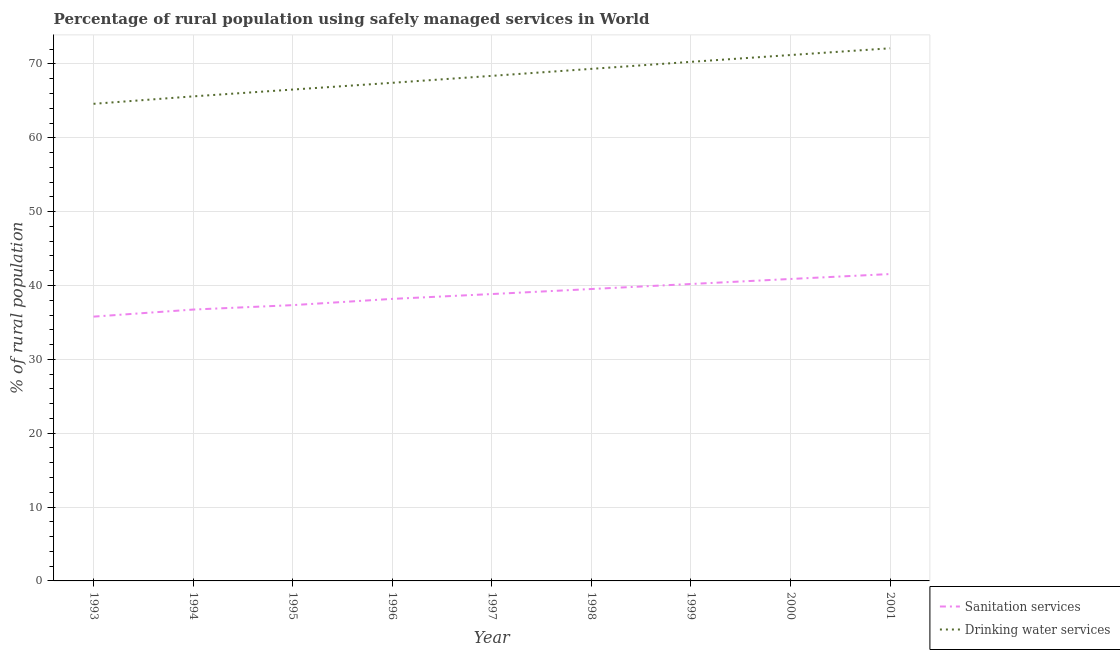Is the number of lines equal to the number of legend labels?
Your response must be concise. Yes. What is the percentage of rural population who used drinking water services in 1995?
Ensure brevity in your answer.  66.53. Across all years, what is the maximum percentage of rural population who used drinking water services?
Your answer should be very brief. 72.12. Across all years, what is the minimum percentage of rural population who used drinking water services?
Offer a terse response. 64.6. In which year was the percentage of rural population who used sanitation services minimum?
Give a very brief answer. 1993. What is the total percentage of rural population who used drinking water services in the graph?
Keep it short and to the point. 615.5. What is the difference between the percentage of rural population who used sanitation services in 1997 and that in 2000?
Your answer should be very brief. -2.04. What is the difference between the percentage of rural population who used sanitation services in 1997 and the percentage of rural population who used drinking water services in 1996?
Your answer should be compact. -28.6. What is the average percentage of rural population who used drinking water services per year?
Offer a terse response. 68.39. In the year 2000, what is the difference between the percentage of rural population who used sanitation services and percentage of rural population who used drinking water services?
Your answer should be compact. -30.32. In how many years, is the percentage of rural population who used drinking water services greater than 18 %?
Offer a terse response. 9. What is the ratio of the percentage of rural population who used sanitation services in 1996 to that in 1999?
Provide a short and direct response. 0.95. Is the percentage of rural population who used drinking water services in 1995 less than that in 1997?
Your response must be concise. Yes. Is the difference between the percentage of rural population who used drinking water services in 1998 and 1999 greater than the difference between the percentage of rural population who used sanitation services in 1998 and 1999?
Your answer should be very brief. No. What is the difference between the highest and the second highest percentage of rural population who used drinking water services?
Provide a succinct answer. 0.91. What is the difference between the highest and the lowest percentage of rural population who used drinking water services?
Make the answer very short. 7.52. In how many years, is the percentage of rural population who used drinking water services greater than the average percentage of rural population who used drinking water services taken over all years?
Your answer should be compact. 4. Does the percentage of rural population who used sanitation services monotonically increase over the years?
Offer a very short reply. Yes. How many lines are there?
Make the answer very short. 2. What is the difference between two consecutive major ticks on the Y-axis?
Offer a very short reply. 10. Are the values on the major ticks of Y-axis written in scientific E-notation?
Your response must be concise. No. Does the graph contain any zero values?
Your response must be concise. No. Does the graph contain grids?
Keep it short and to the point. Yes. How many legend labels are there?
Your response must be concise. 2. How are the legend labels stacked?
Provide a succinct answer. Vertical. What is the title of the graph?
Keep it short and to the point. Percentage of rural population using safely managed services in World. Does "Under-five" appear as one of the legend labels in the graph?
Give a very brief answer. No. What is the label or title of the X-axis?
Offer a terse response. Year. What is the label or title of the Y-axis?
Keep it short and to the point. % of rural population. What is the % of rural population of Sanitation services in 1993?
Give a very brief answer. 35.78. What is the % of rural population in Drinking water services in 1993?
Offer a very short reply. 64.6. What is the % of rural population of Sanitation services in 1994?
Provide a succinct answer. 36.74. What is the % of rural population of Drinking water services in 1994?
Make the answer very short. 65.61. What is the % of rural population in Sanitation services in 1995?
Provide a short and direct response. 37.34. What is the % of rural population in Drinking water services in 1995?
Ensure brevity in your answer.  66.53. What is the % of rural population of Sanitation services in 1996?
Offer a very short reply. 38.19. What is the % of rural population in Drinking water services in 1996?
Your answer should be very brief. 67.44. What is the % of rural population of Sanitation services in 1997?
Ensure brevity in your answer.  38.84. What is the % of rural population in Drinking water services in 1997?
Give a very brief answer. 68.38. What is the % of rural population in Sanitation services in 1998?
Give a very brief answer. 39.52. What is the % of rural population in Drinking water services in 1998?
Offer a very short reply. 69.33. What is the % of rural population in Sanitation services in 1999?
Provide a short and direct response. 40.2. What is the % of rural population of Drinking water services in 1999?
Your response must be concise. 70.28. What is the % of rural population of Sanitation services in 2000?
Your response must be concise. 40.88. What is the % of rural population of Drinking water services in 2000?
Offer a terse response. 71.2. What is the % of rural population in Sanitation services in 2001?
Give a very brief answer. 41.55. What is the % of rural population in Drinking water services in 2001?
Keep it short and to the point. 72.12. Across all years, what is the maximum % of rural population of Sanitation services?
Provide a short and direct response. 41.55. Across all years, what is the maximum % of rural population of Drinking water services?
Ensure brevity in your answer.  72.12. Across all years, what is the minimum % of rural population in Sanitation services?
Provide a succinct answer. 35.78. Across all years, what is the minimum % of rural population in Drinking water services?
Your answer should be compact. 64.6. What is the total % of rural population in Sanitation services in the graph?
Your response must be concise. 349.06. What is the total % of rural population in Drinking water services in the graph?
Make the answer very short. 615.5. What is the difference between the % of rural population in Sanitation services in 1993 and that in 1994?
Offer a terse response. -0.96. What is the difference between the % of rural population in Drinking water services in 1993 and that in 1994?
Your response must be concise. -1.01. What is the difference between the % of rural population of Sanitation services in 1993 and that in 1995?
Provide a succinct answer. -1.56. What is the difference between the % of rural population in Drinking water services in 1993 and that in 1995?
Ensure brevity in your answer.  -1.93. What is the difference between the % of rural population in Sanitation services in 1993 and that in 1996?
Keep it short and to the point. -2.4. What is the difference between the % of rural population of Drinking water services in 1993 and that in 1996?
Make the answer very short. -2.84. What is the difference between the % of rural population of Sanitation services in 1993 and that in 1997?
Make the answer very short. -3.06. What is the difference between the % of rural population of Drinking water services in 1993 and that in 1997?
Offer a terse response. -3.79. What is the difference between the % of rural population of Sanitation services in 1993 and that in 1998?
Offer a very short reply. -3.74. What is the difference between the % of rural population of Drinking water services in 1993 and that in 1998?
Provide a succinct answer. -4.73. What is the difference between the % of rural population in Sanitation services in 1993 and that in 1999?
Offer a terse response. -4.42. What is the difference between the % of rural population of Drinking water services in 1993 and that in 1999?
Keep it short and to the point. -5.68. What is the difference between the % of rural population of Sanitation services in 1993 and that in 2000?
Offer a terse response. -5.1. What is the difference between the % of rural population of Drinking water services in 1993 and that in 2000?
Your answer should be very brief. -6.61. What is the difference between the % of rural population of Sanitation services in 1993 and that in 2001?
Provide a short and direct response. -5.77. What is the difference between the % of rural population in Drinking water services in 1993 and that in 2001?
Provide a succinct answer. -7.52. What is the difference between the % of rural population in Sanitation services in 1994 and that in 1995?
Your answer should be very brief. -0.6. What is the difference between the % of rural population in Drinking water services in 1994 and that in 1995?
Offer a very short reply. -0.92. What is the difference between the % of rural population of Sanitation services in 1994 and that in 1996?
Keep it short and to the point. -1.45. What is the difference between the % of rural population of Drinking water services in 1994 and that in 1996?
Your answer should be very brief. -1.84. What is the difference between the % of rural population of Sanitation services in 1994 and that in 1997?
Your response must be concise. -2.1. What is the difference between the % of rural population of Drinking water services in 1994 and that in 1997?
Your answer should be compact. -2.78. What is the difference between the % of rural population of Sanitation services in 1994 and that in 1998?
Keep it short and to the point. -2.78. What is the difference between the % of rural population in Drinking water services in 1994 and that in 1998?
Your answer should be very brief. -3.73. What is the difference between the % of rural population of Sanitation services in 1994 and that in 1999?
Provide a succinct answer. -3.46. What is the difference between the % of rural population of Drinking water services in 1994 and that in 1999?
Give a very brief answer. -4.68. What is the difference between the % of rural population of Sanitation services in 1994 and that in 2000?
Your answer should be compact. -4.14. What is the difference between the % of rural population of Drinking water services in 1994 and that in 2000?
Give a very brief answer. -5.6. What is the difference between the % of rural population of Sanitation services in 1994 and that in 2001?
Provide a succinct answer. -4.81. What is the difference between the % of rural population in Drinking water services in 1994 and that in 2001?
Your response must be concise. -6.51. What is the difference between the % of rural population of Sanitation services in 1995 and that in 1996?
Ensure brevity in your answer.  -0.84. What is the difference between the % of rural population in Drinking water services in 1995 and that in 1996?
Ensure brevity in your answer.  -0.91. What is the difference between the % of rural population of Sanitation services in 1995 and that in 1997?
Ensure brevity in your answer.  -1.5. What is the difference between the % of rural population of Drinking water services in 1995 and that in 1997?
Keep it short and to the point. -1.86. What is the difference between the % of rural population of Sanitation services in 1995 and that in 1998?
Your response must be concise. -2.18. What is the difference between the % of rural population in Drinking water services in 1995 and that in 1998?
Your answer should be very brief. -2.8. What is the difference between the % of rural population in Sanitation services in 1995 and that in 1999?
Provide a short and direct response. -2.86. What is the difference between the % of rural population in Drinking water services in 1995 and that in 1999?
Offer a very short reply. -3.75. What is the difference between the % of rural population of Sanitation services in 1995 and that in 2000?
Your answer should be very brief. -3.54. What is the difference between the % of rural population of Drinking water services in 1995 and that in 2000?
Make the answer very short. -4.68. What is the difference between the % of rural population of Sanitation services in 1995 and that in 2001?
Give a very brief answer. -4.21. What is the difference between the % of rural population in Drinking water services in 1995 and that in 2001?
Your answer should be very brief. -5.59. What is the difference between the % of rural population in Sanitation services in 1996 and that in 1997?
Your answer should be very brief. -0.66. What is the difference between the % of rural population in Drinking water services in 1996 and that in 1997?
Your response must be concise. -0.94. What is the difference between the % of rural population in Sanitation services in 1996 and that in 1998?
Offer a very short reply. -1.34. What is the difference between the % of rural population of Drinking water services in 1996 and that in 1998?
Ensure brevity in your answer.  -1.89. What is the difference between the % of rural population of Sanitation services in 1996 and that in 1999?
Make the answer very short. -2.02. What is the difference between the % of rural population of Drinking water services in 1996 and that in 1999?
Provide a succinct answer. -2.84. What is the difference between the % of rural population in Sanitation services in 1996 and that in 2000?
Offer a terse response. -2.7. What is the difference between the % of rural population in Drinking water services in 1996 and that in 2000?
Make the answer very short. -3.76. What is the difference between the % of rural population in Sanitation services in 1996 and that in 2001?
Your answer should be very brief. -3.36. What is the difference between the % of rural population in Drinking water services in 1996 and that in 2001?
Provide a short and direct response. -4.67. What is the difference between the % of rural population of Sanitation services in 1997 and that in 1998?
Provide a succinct answer. -0.68. What is the difference between the % of rural population in Drinking water services in 1997 and that in 1998?
Offer a very short reply. -0.95. What is the difference between the % of rural population of Sanitation services in 1997 and that in 1999?
Offer a terse response. -1.36. What is the difference between the % of rural population in Drinking water services in 1997 and that in 1999?
Keep it short and to the point. -1.9. What is the difference between the % of rural population of Sanitation services in 1997 and that in 2000?
Your answer should be compact. -2.04. What is the difference between the % of rural population of Drinking water services in 1997 and that in 2000?
Offer a terse response. -2.82. What is the difference between the % of rural population of Sanitation services in 1997 and that in 2001?
Give a very brief answer. -2.71. What is the difference between the % of rural population in Drinking water services in 1997 and that in 2001?
Make the answer very short. -3.73. What is the difference between the % of rural population in Sanitation services in 1998 and that in 1999?
Provide a short and direct response. -0.68. What is the difference between the % of rural population in Drinking water services in 1998 and that in 1999?
Offer a very short reply. -0.95. What is the difference between the % of rural population in Sanitation services in 1998 and that in 2000?
Keep it short and to the point. -1.36. What is the difference between the % of rural population in Drinking water services in 1998 and that in 2000?
Provide a succinct answer. -1.87. What is the difference between the % of rural population of Sanitation services in 1998 and that in 2001?
Keep it short and to the point. -2.03. What is the difference between the % of rural population of Drinking water services in 1998 and that in 2001?
Provide a succinct answer. -2.78. What is the difference between the % of rural population of Sanitation services in 1999 and that in 2000?
Ensure brevity in your answer.  -0.68. What is the difference between the % of rural population of Drinking water services in 1999 and that in 2000?
Provide a short and direct response. -0.92. What is the difference between the % of rural population of Sanitation services in 1999 and that in 2001?
Your answer should be very brief. -1.35. What is the difference between the % of rural population in Drinking water services in 1999 and that in 2001?
Provide a succinct answer. -1.83. What is the difference between the % of rural population of Sanitation services in 2000 and that in 2001?
Provide a short and direct response. -0.67. What is the difference between the % of rural population of Drinking water services in 2000 and that in 2001?
Your answer should be very brief. -0.91. What is the difference between the % of rural population of Sanitation services in 1993 and the % of rural population of Drinking water services in 1994?
Keep it short and to the point. -29.82. What is the difference between the % of rural population in Sanitation services in 1993 and the % of rural population in Drinking water services in 1995?
Keep it short and to the point. -30.75. What is the difference between the % of rural population in Sanitation services in 1993 and the % of rural population in Drinking water services in 1996?
Offer a terse response. -31.66. What is the difference between the % of rural population of Sanitation services in 1993 and the % of rural population of Drinking water services in 1997?
Keep it short and to the point. -32.6. What is the difference between the % of rural population of Sanitation services in 1993 and the % of rural population of Drinking water services in 1998?
Provide a short and direct response. -33.55. What is the difference between the % of rural population of Sanitation services in 1993 and the % of rural population of Drinking water services in 1999?
Your response must be concise. -34.5. What is the difference between the % of rural population of Sanitation services in 1993 and the % of rural population of Drinking water services in 2000?
Ensure brevity in your answer.  -35.42. What is the difference between the % of rural population in Sanitation services in 1993 and the % of rural population in Drinking water services in 2001?
Your response must be concise. -36.33. What is the difference between the % of rural population of Sanitation services in 1994 and the % of rural population of Drinking water services in 1995?
Offer a terse response. -29.79. What is the difference between the % of rural population of Sanitation services in 1994 and the % of rural population of Drinking water services in 1996?
Your response must be concise. -30.7. What is the difference between the % of rural population of Sanitation services in 1994 and the % of rural population of Drinking water services in 1997?
Provide a succinct answer. -31.64. What is the difference between the % of rural population in Sanitation services in 1994 and the % of rural population in Drinking water services in 1998?
Give a very brief answer. -32.59. What is the difference between the % of rural population of Sanitation services in 1994 and the % of rural population of Drinking water services in 1999?
Your answer should be compact. -33.54. What is the difference between the % of rural population of Sanitation services in 1994 and the % of rural population of Drinking water services in 2000?
Offer a very short reply. -34.46. What is the difference between the % of rural population of Sanitation services in 1994 and the % of rural population of Drinking water services in 2001?
Provide a short and direct response. -35.38. What is the difference between the % of rural population in Sanitation services in 1995 and the % of rural population in Drinking water services in 1996?
Provide a succinct answer. -30.1. What is the difference between the % of rural population in Sanitation services in 1995 and the % of rural population in Drinking water services in 1997?
Offer a very short reply. -31.04. What is the difference between the % of rural population in Sanitation services in 1995 and the % of rural population in Drinking water services in 1998?
Give a very brief answer. -31.99. What is the difference between the % of rural population of Sanitation services in 1995 and the % of rural population of Drinking water services in 1999?
Keep it short and to the point. -32.94. What is the difference between the % of rural population of Sanitation services in 1995 and the % of rural population of Drinking water services in 2000?
Give a very brief answer. -33.86. What is the difference between the % of rural population in Sanitation services in 1995 and the % of rural population in Drinking water services in 2001?
Ensure brevity in your answer.  -34.78. What is the difference between the % of rural population in Sanitation services in 1996 and the % of rural population in Drinking water services in 1997?
Ensure brevity in your answer.  -30.2. What is the difference between the % of rural population of Sanitation services in 1996 and the % of rural population of Drinking water services in 1998?
Your response must be concise. -31.15. What is the difference between the % of rural population of Sanitation services in 1996 and the % of rural population of Drinking water services in 1999?
Your response must be concise. -32.1. What is the difference between the % of rural population in Sanitation services in 1996 and the % of rural population in Drinking water services in 2000?
Make the answer very short. -33.02. What is the difference between the % of rural population in Sanitation services in 1996 and the % of rural population in Drinking water services in 2001?
Your response must be concise. -33.93. What is the difference between the % of rural population of Sanitation services in 1997 and the % of rural population of Drinking water services in 1998?
Keep it short and to the point. -30.49. What is the difference between the % of rural population in Sanitation services in 1997 and the % of rural population in Drinking water services in 1999?
Ensure brevity in your answer.  -31.44. What is the difference between the % of rural population in Sanitation services in 1997 and the % of rural population in Drinking water services in 2000?
Provide a short and direct response. -32.36. What is the difference between the % of rural population of Sanitation services in 1997 and the % of rural population of Drinking water services in 2001?
Your answer should be compact. -33.27. What is the difference between the % of rural population of Sanitation services in 1998 and the % of rural population of Drinking water services in 1999?
Offer a terse response. -30.76. What is the difference between the % of rural population of Sanitation services in 1998 and the % of rural population of Drinking water services in 2000?
Your answer should be very brief. -31.68. What is the difference between the % of rural population of Sanitation services in 1998 and the % of rural population of Drinking water services in 2001?
Provide a short and direct response. -32.59. What is the difference between the % of rural population in Sanitation services in 1999 and the % of rural population in Drinking water services in 2000?
Offer a terse response. -31. What is the difference between the % of rural population of Sanitation services in 1999 and the % of rural population of Drinking water services in 2001?
Keep it short and to the point. -31.91. What is the difference between the % of rural population in Sanitation services in 2000 and the % of rural population in Drinking water services in 2001?
Your response must be concise. -31.23. What is the average % of rural population in Sanitation services per year?
Offer a very short reply. 38.78. What is the average % of rural population of Drinking water services per year?
Your response must be concise. 68.39. In the year 1993, what is the difference between the % of rural population of Sanitation services and % of rural population of Drinking water services?
Keep it short and to the point. -28.81. In the year 1994, what is the difference between the % of rural population of Sanitation services and % of rural population of Drinking water services?
Give a very brief answer. -28.87. In the year 1995, what is the difference between the % of rural population of Sanitation services and % of rural population of Drinking water services?
Give a very brief answer. -29.19. In the year 1996, what is the difference between the % of rural population in Sanitation services and % of rural population in Drinking water services?
Provide a short and direct response. -29.26. In the year 1997, what is the difference between the % of rural population in Sanitation services and % of rural population in Drinking water services?
Keep it short and to the point. -29.54. In the year 1998, what is the difference between the % of rural population in Sanitation services and % of rural population in Drinking water services?
Provide a short and direct response. -29.81. In the year 1999, what is the difference between the % of rural population of Sanitation services and % of rural population of Drinking water services?
Your answer should be very brief. -30.08. In the year 2000, what is the difference between the % of rural population of Sanitation services and % of rural population of Drinking water services?
Your answer should be compact. -30.32. In the year 2001, what is the difference between the % of rural population of Sanitation services and % of rural population of Drinking water services?
Your response must be concise. -30.57. What is the ratio of the % of rural population in Sanitation services in 1993 to that in 1994?
Your answer should be compact. 0.97. What is the ratio of the % of rural population of Drinking water services in 1993 to that in 1994?
Provide a short and direct response. 0.98. What is the ratio of the % of rural population in Sanitation services in 1993 to that in 1995?
Your answer should be compact. 0.96. What is the ratio of the % of rural population in Drinking water services in 1993 to that in 1995?
Give a very brief answer. 0.97. What is the ratio of the % of rural population in Sanitation services in 1993 to that in 1996?
Provide a succinct answer. 0.94. What is the ratio of the % of rural population of Drinking water services in 1993 to that in 1996?
Your answer should be compact. 0.96. What is the ratio of the % of rural population of Sanitation services in 1993 to that in 1997?
Keep it short and to the point. 0.92. What is the ratio of the % of rural population of Drinking water services in 1993 to that in 1997?
Make the answer very short. 0.94. What is the ratio of the % of rural population of Sanitation services in 1993 to that in 1998?
Ensure brevity in your answer.  0.91. What is the ratio of the % of rural population in Drinking water services in 1993 to that in 1998?
Offer a terse response. 0.93. What is the ratio of the % of rural population of Sanitation services in 1993 to that in 1999?
Provide a short and direct response. 0.89. What is the ratio of the % of rural population of Drinking water services in 1993 to that in 1999?
Provide a succinct answer. 0.92. What is the ratio of the % of rural population of Sanitation services in 1993 to that in 2000?
Give a very brief answer. 0.88. What is the ratio of the % of rural population of Drinking water services in 1993 to that in 2000?
Offer a terse response. 0.91. What is the ratio of the % of rural population of Sanitation services in 1993 to that in 2001?
Offer a very short reply. 0.86. What is the ratio of the % of rural population in Drinking water services in 1993 to that in 2001?
Ensure brevity in your answer.  0.9. What is the ratio of the % of rural population in Sanitation services in 1994 to that in 1995?
Make the answer very short. 0.98. What is the ratio of the % of rural population of Drinking water services in 1994 to that in 1995?
Provide a short and direct response. 0.99. What is the ratio of the % of rural population of Sanitation services in 1994 to that in 1996?
Offer a terse response. 0.96. What is the ratio of the % of rural population of Drinking water services in 1994 to that in 1996?
Provide a short and direct response. 0.97. What is the ratio of the % of rural population in Sanitation services in 1994 to that in 1997?
Ensure brevity in your answer.  0.95. What is the ratio of the % of rural population in Drinking water services in 1994 to that in 1997?
Keep it short and to the point. 0.96. What is the ratio of the % of rural population in Sanitation services in 1994 to that in 1998?
Ensure brevity in your answer.  0.93. What is the ratio of the % of rural population in Drinking water services in 1994 to that in 1998?
Provide a succinct answer. 0.95. What is the ratio of the % of rural population of Sanitation services in 1994 to that in 1999?
Offer a terse response. 0.91. What is the ratio of the % of rural population in Drinking water services in 1994 to that in 1999?
Ensure brevity in your answer.  0.93. What is the ratio of the % of rural population in Sanitation services in 1994 to that in 2000?
Offer a very short reply. 0.9. What is the ratio of the % of rural population in Drinking water services in 1994 to that in 2000?
Your answer should be compact. 0.92. What is the ratio of the % of rural population in Sanitation services in 1994 to that in 2001?
Make the answer very short. 0.88. What is the ratio of the % of rural population of Drinking water services in 1994 to that in 2001?
Ensure brevity in your answer.  0.91. What is the ratio of the % of rural population of Sanitation services in 1995 to that in 1996?
Your answer should be very brief. 0.98. What is the ratio of the % of rural population of Drinking water services in 1995 to that in 1996?
Give a very brief answer. 0.99. What is the ratio of the % of rural population of Sanitation services in 1995 to that in 1997?
Provide a succinct answer. 0.96. What is the ratio of the % of rural population in Drinking water services in 1995 to that in 1997?
Your answer should be compact. 0.97. What is the ratio of the % of rural population of Sanitation services in 1995 to that in 1998?
Provide a short and direct response. 0.94. What is the ratio of the % of rural population in Drinking water services in 1995 to that in 1998?
Your answer should be very brief. 0.96. What is the ratio of the % of rural population of Sanitation services in 1995 to that in 1999?
Make the answer very short. 0.93. What is the ratio of the % of rural population of Drinking water services in 1995 to that in 1999?
Your response must be concise. 0.95. What is the ratio of the % of rural population in Sanitation services in 1995 to that in 2000?
Your answer should be very brief. 0.91. What is the ratio of the % of rural population of Drinking water services in 1995 to that in 2000?
Ensure brevity in your answer.  0.93. What is the ratio of the % of rural population of Sanitation services in 1995 to that in 2001?
Make the answer very short. 0.9. What is the ratio of the % of rural population of Drinking water services in 1995 to that in 2001?
Your answer should be very brief. 0.92. What is the ratio of the % of rural population in Sanitation services in 1996 to that in 1997?
Provide a succinct answer. 0.98. What is the ratio of the % of rural population of Drinking water services in 1996 to that in 1997?
Offer a very short reply. 0.99. What is the ratio of the % of rural population in Sanitation services in 1996 to that in 1998?
Your response must be concise. 0.97. What is the ratio of the % of rural population of Drinking water services in 1996 to that in 1998?
Provide a succinct answer. 0.97. What is the ratio of the % of rural population of Sanitation services in 1996 to that in 1999?
Provide a short and direct response. 0.95. What is the ratio of the % of rural population in Drinking water services in 1996 to that in 1999?
Provide a short and direct response. 0.96. What is the ratio of the % of rural population of Sanitation services in 1996 to that in 2000?
Give a very brief answer. 0.93. What is the ratio of the % of rural population of Drinking water services in 1996 to that in 2000?
Offer a terse response. 0.95. What is the ratio of the % of rural population of Sanitation services in 1996 to that in 2001?
Your response must be concise. 0.92. What is the ratio of the % of rural population of Drinking water services in 1996 to that in 2001?
Offer a terse response. 0.94. What is the ratio of the % of rural population in Sanitation services in 1997 to that in 1998?
Provide a short and direct response. 0.98. What is the ratio of the % of rural population of Drinking water services in 1997 to that in 1998?
Offer a very short reply. 0.99. What is the ratio of the % of rural population in Sanitation services in 1997 to that in 1999?
Make the answer very short. 0.97. What is the ratio of the % of rural population of Sanitation services in 1997 to that in 2000?
Offer a terse response. 0.95. What is the ratio of the % of rural population of Drinking water services in 1997 to that in 2000?
Offer a very short reply. 0.96. What is the ratio of the % of rural population of Sanitation services in 1997 to that in 2001?
Ensure brevity in your answer.  0.93. What is the ratio of the % of rural population of Drinking water services in 1997 to that in 2001?
Your response must be concise. 0.95. What is the ratio of the % of rural population of Sanitation services in 1998 to that in 1999?
Make the answer very short. 0.98. What is the ratio of the % of rural population of Drinking water services in 1998 to that in 1999?
Provide a short and direct response. 0.99. What is the ratio of the % of rural population in Sanitation services in 1998 to that in 2000?
Offer a very short reply. 0.97. What is the ratio of the % of rural population of Drinking water services in 1998 to that in 2000?
Make the answer very short. 0.97. What is the ratio of the % of rural population of Sanitation services in 1998 to that in 2001?
Offer a terse response. 0.95. What is the ratio of the % of rural population of Drinking water services in 1998 to that in 2001?
Ensure brevity in your answer.  0.96. What is the ratio of the % of rural population in Sanitation services in 1999 to that in 2000?
Your answer should be compact. 0.98. What is the ratio of the % of rural population of Drinking water services in 1999 to that in 2000?
Your response must be concise. 0.99. What is the ratio of the % of rural population of Sanitation services in 1999 to that in 2001?
Your response must be concise. 0.97. What is the ratio of the % of rural population in Drinking water services in 1999 to that in 2001?
Ensure brevity in your answer.  0.97. What is the ratio of the % of rural population of Drinking water services in 2000 to that in 2001?
Ensure brevity in your answer.  0.99. What is the difference between the highest and the second highest % of rural population of Sanitation services?
Your answer should be compact. 0.67. What is the difference between the highest and the second highest % of rural population in Drinking water services?
Make the answer very short. 0.91. What is the difference between the highest and the lowest % of rural population of Sanitation services?
Your answer should be compact. 5.77. What is the difference between the highest and the lowest % of rural population in Drinking water services?
Keep it short and to the point. 7.52. 